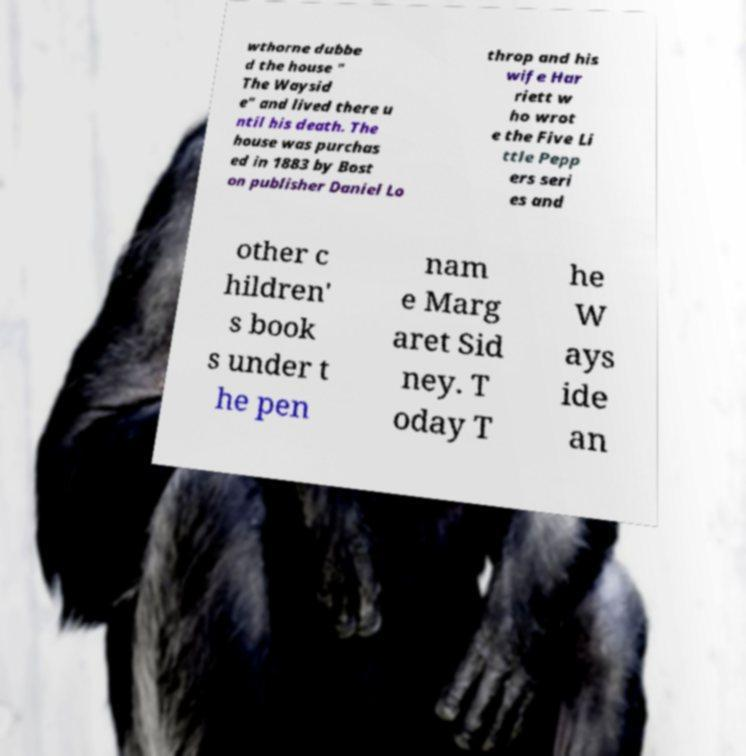I need the written content from this picture converted into text. Can you do that? wthorne dubbe d the house " The Waysid e" and lived there u ntil his death. The house was purchas ed in 1883 by Bost on publisher Daniel Lo throp and his wife Har riett w ho wrot e the Five Li ttle Pepp ers seri es and other c hildren' s book s under t he pen nam e Marg aret Sid ney. T oday T he W ays ide an 